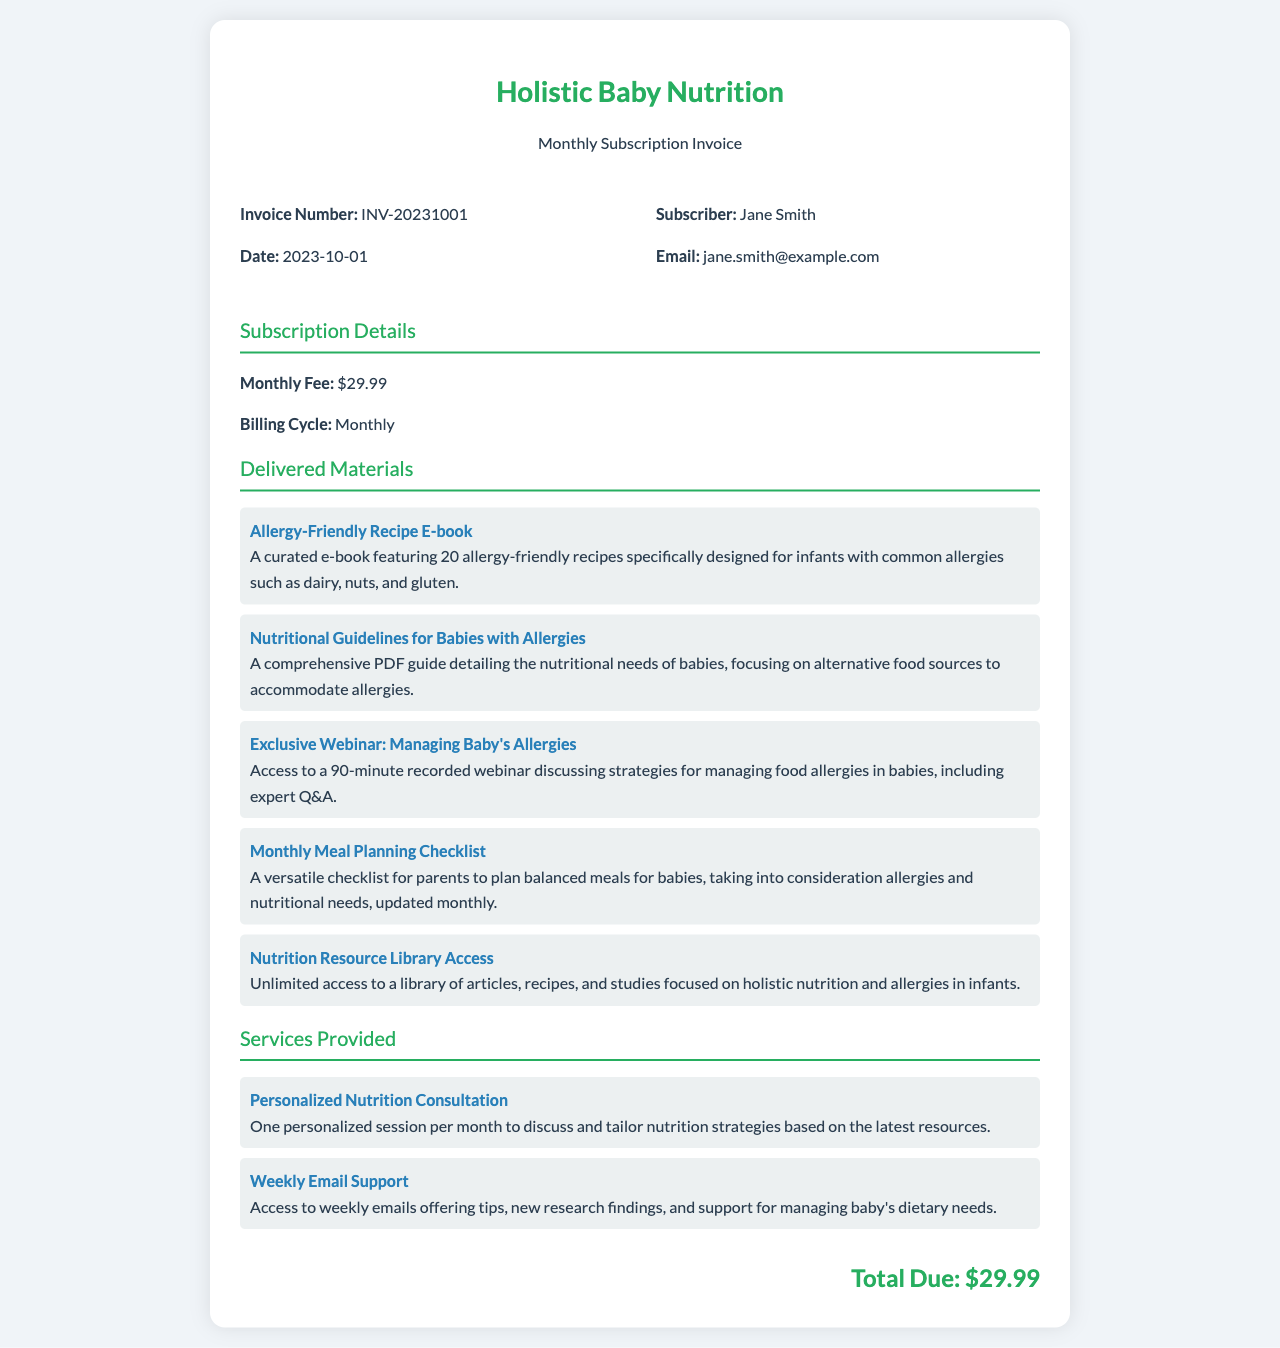What is the invoice number? The invoice number is specified in the document as a unique identifier for this transaction.
Answer: INV-20231001 What is the date of the invoice? The date indicates when the invoice was issued, which can be found in the document.
Answer: 2023-10-01 Who is the subscriber? The subscriber's name is provided in the invoice, identifying the individual receiving the services.
Answer: Jane Smith What is the monthly fee? The monthly fee is detailed in the subscription section of the invoice as the cost for access to resources.
Answer: $29.99 Name one of the delivered materials. The delivered materials list outlines specific resources provided to the subscriber monthly, one of which is listed.
Answer: Allergy-Friendly Recipe E-book What type of service includes personalized sessions? The services provided section details various types of assistance available to the subscriber, including specific tailored sessions.
Answer: Personalized Nutrition Consultation What is the total due amount? The total due amount summarizes the costs for the services and materials for the month as noted at the end of the invoice.
Answer: $29.99 What is the billing cycle? The billing cycle specifies how often the subscriber will be charged, which is mentioned in the document.
Answer: Monthly How many recipes are featured in the Allergy-Friendly Recipe E-book? The document specifies the number of recipes included in this specific resource, allowing readers to understand its content.
Answer: 20 